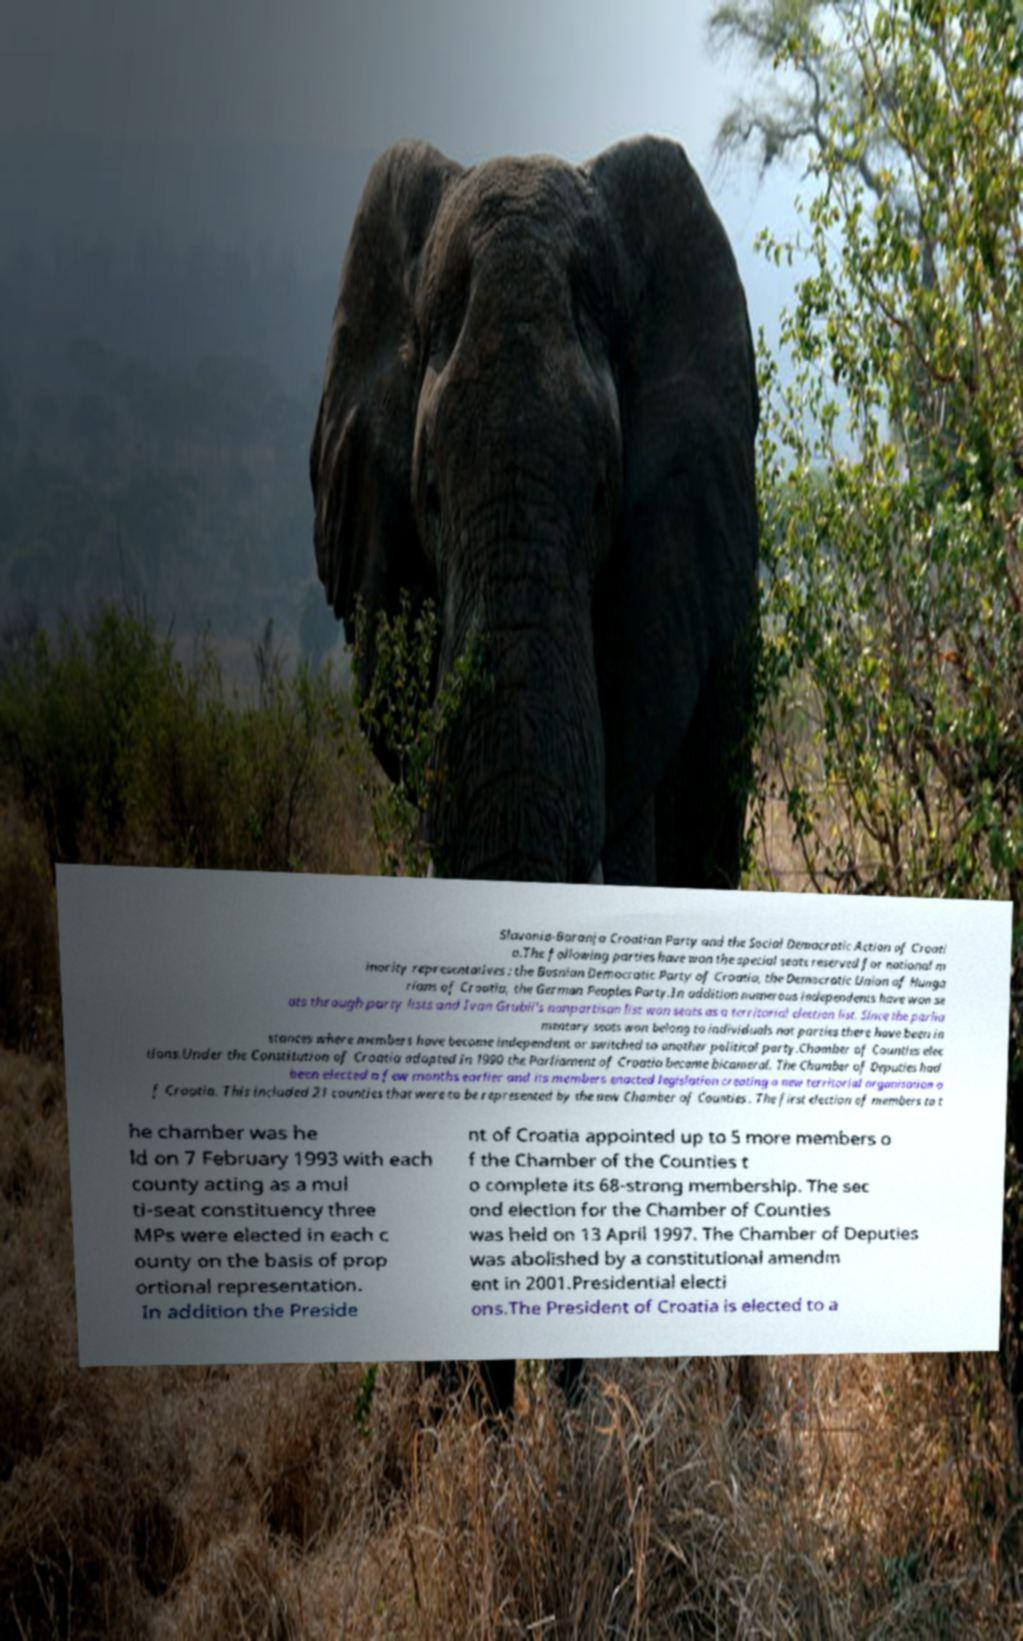Please read and relay the text visible in this image. What does it say? Slavonia-Baranja Croatian Party and the Social Democratic Action of Croati a.The following parties have won the special seats reserved for national m inority representatives : the Bosnian Democratic Party of Croatia, the Democratic Union of Hunga rians of Croatia, the German Peoples Party.In addition numerous independents have won se ats through party lists and Ivan Grubii's nonpartisan list won seats as a territorial election list. Since the parlia mentary seats won belong to individuals not parties there have been in stances where members have become independent or switched to another political party.Chamber of Counties elec tions.Under the Constitution of Croatia adopted in 1990 the Parliament of Croatia became bicameral. The Chamber of Deputies had been elected a few months earlier and its members enacted legislation creating a new territorial organisation o f Croatia. This included 21 counties that were to be represented by the new Chamber of Counties . The first election of members to t he chamber was he ld on 7 February 1993 with each county acting as a mul ti-seat constituency three MPs were elected in each c ounty on the basis of prop ortional representation. In addition the Preside nt of Croatia appointed up to 5 more members o f the Chamber of the Counties t o complete its 68-strong membership. The sec ond election for the Chamber of Counties was held on 13 April 1997. The Chamber of Deputies was abolished by a constitutional amendm ent in 2001.Presidential electi ons.The President of Croatia is elected to a 